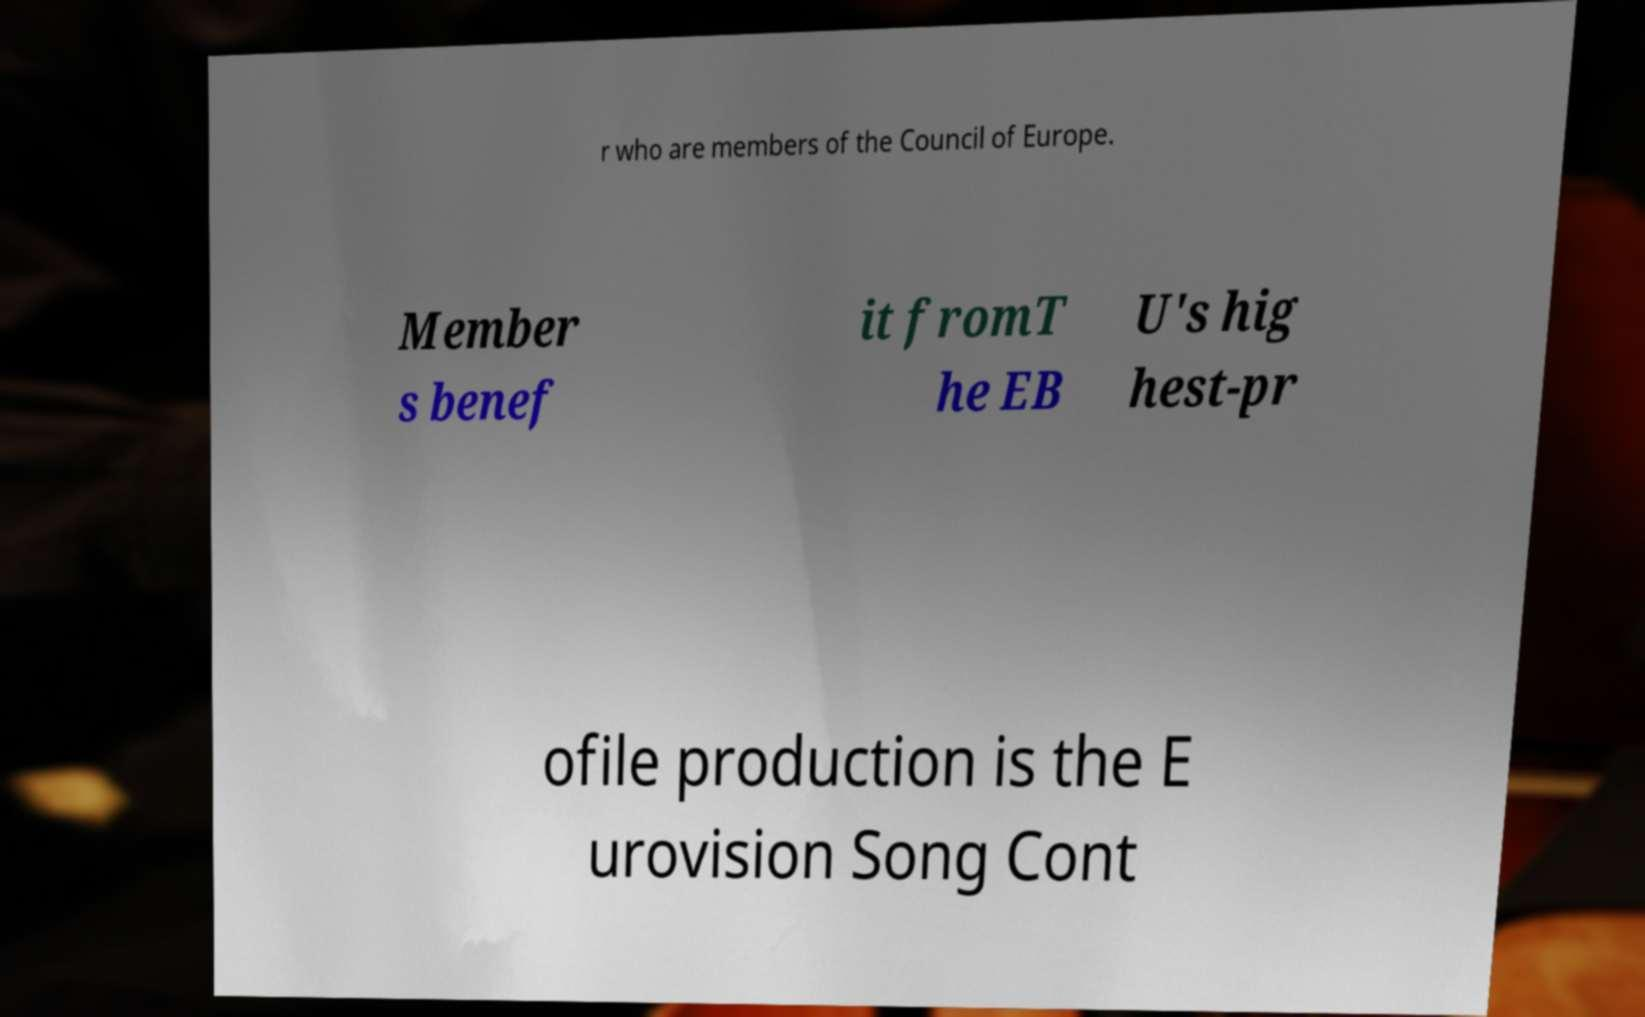What messages or text are displayed in this image? I need them in a readable, typed format. r who are members of the Council of Europe. Member s benef it fromT he EB U's hig hest-pr ofile production is the E urovision Song Cont 